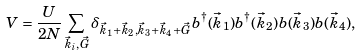Convert formula to latex. <formula><loc_0><loc_0><loc_500><loc_500>V = \frac { U } { 2 N } \sum _ { \vec { k } _ { i } , \vec { G } } \delta _ { \vec { k } _ { 1 } + \vec { k } _ { 2 } , \vec { k } _ { 3 } + \vec { k } _ { 4 } + \vec { G } } b ^ { \dagger } ( \vec { k } _ { 1 } ) b ^ { \dagger } ( \vec { k } _ { 2 } ) b ( \vec { k } _ { 3 } ) b ( \vec { k } _ { 4 } ) ,</formula> 